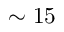Convert formula to latex. <formula><loc_0><loc_0><loc_500><loc_500>\sim 1 5</formula> 